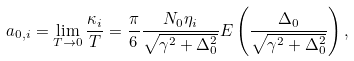Convert formula to latex. <formula><loc_0><loc_0><loc_500><loc_500>a _ { 0 , i } = \lim _ { T \rightarrow 0 } \frac { \kappa _ { i } } { T } = \frac { \pi } { 6 } \frac { N _ { 0 } \eta _ { i } } { \sqrt { \gamma ^ { 2 } + \Delta _ { 0 } ^ { 2 } } } E \left ( \frac { \Delta _ { 0 } } { \sqrt { \gamma ^ { 2 } + \Delta _ { 0 } ^ { 2 } } } \right ) ,</formula> 